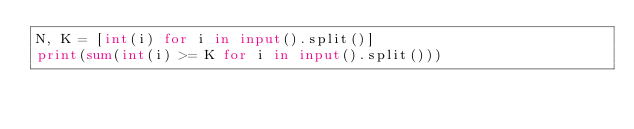<code> <loc_0><loc_0><loc_500><loc_500><_Python_>N, K = [int(i) for i in input().split()]
print(sum(int(i) >= K for i in input().split()))</code> 